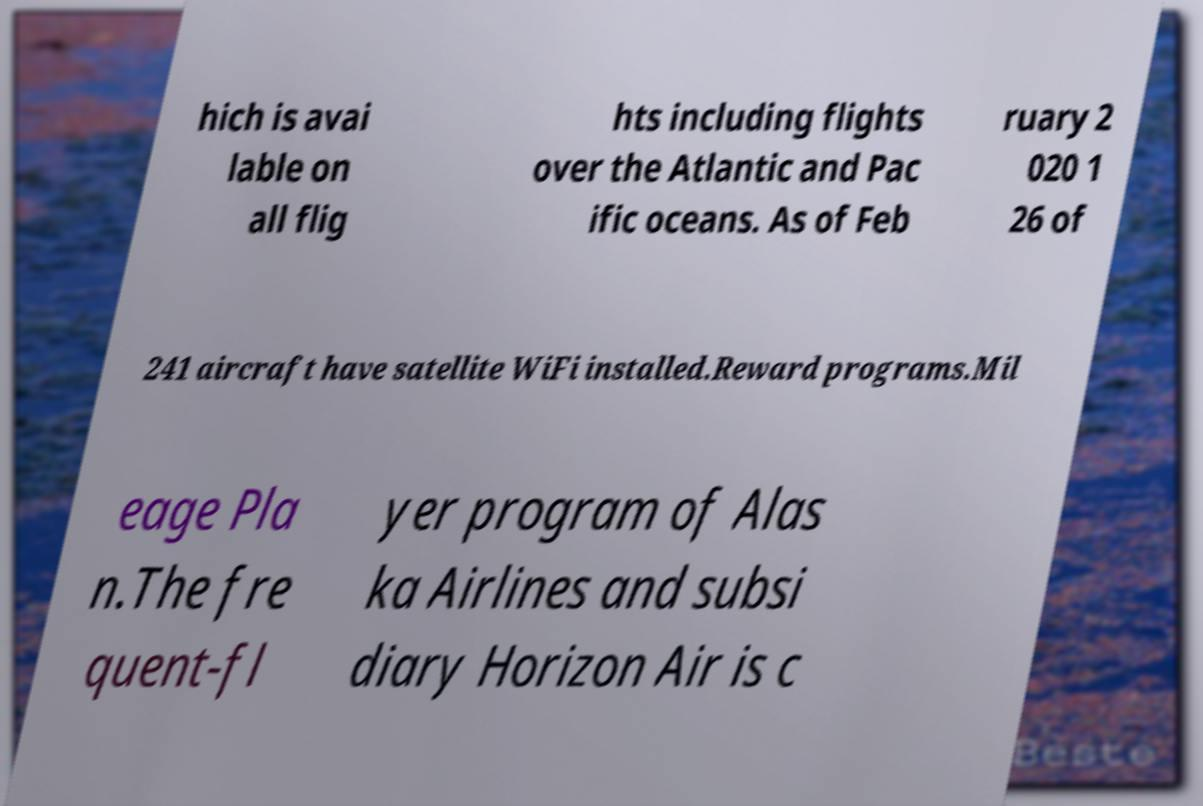For documentation purposes, I need the text within this image transcribed. Could you provide that? hich is avai lable on all flig hts including flights over the Atlantic and Pac ific oceans. As of Feb ruary 2 020 1 26 of 241 aircraft have satellite WiFi installed.Reward programs.Mil eage Pla n.The fre quent-fl yer program of Alas ka Airlines and subsi diary Horizon Air is c 